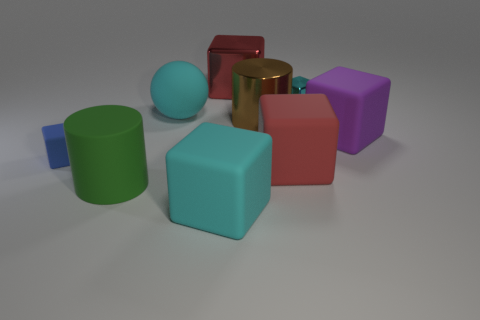Are there fewer big brown cylinders that are to the left of the big brown metallic object than big cyan blocks that are on the right side of the big cyan cube?
Provide a succinct answer. No. What number of other things are there of the same material as the blue object
Provide a short and direct response. 5. Are the big sphere and the big brown cylinder made of the same material?
Offer a very short reply. No. How many other objects are there of the same size as the blue matte thing?
Your answer should be very brief. 1. What is the size of the cylinder that is to the right of the rubber thing in front of the green rubber cylinder?
Provide a succinct answer. Large. The small object behind the thing to the right of the tiny block that is to the right of the big red metal object is what color?
Your answer should be compact. Cyan. There is a matte block that is both to the right of the large cyan block and to the left of the cyan metal object; how big is it?
Provide a short and direct response. Large. How many other objects are there of the same shape as the tiny metallic thing?
Give a very brief answer. 5. How many cylinders are red objects or purple matte objects?
Offer a terse response. 0. There is a big green object in front of the block to the left of the big cyan sphere; is there a object that is in front of it?
Offer a very short reply. Yes. 